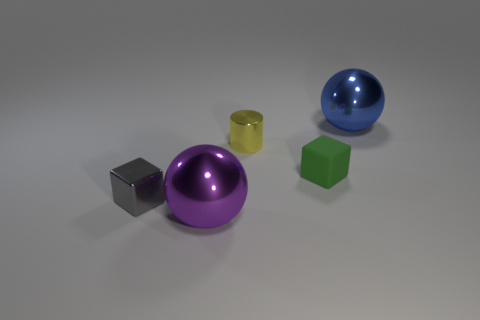Add 2 green objects. How many objects exist? 7 Subtract all cylinders. How many objects are left? 4 Subtract 1 balls. How many balls are left? 1 Subtract all yellow blocks. Subtract all cyan spheres. How many blocks are left? 2 Subtract all red spheres. How many green blocks are left? 1 Subtract all tiny yellow metallic objects. Subtract all green matte objects. How many objects are left? 3 Add 4 tiny yellow shiny things. How many tiny yellow shiny things are left? 5 Add 3 metallic objects. How many metallic objects exist? 7 Subtract 0 red cylinders. How many objects are left? 5 